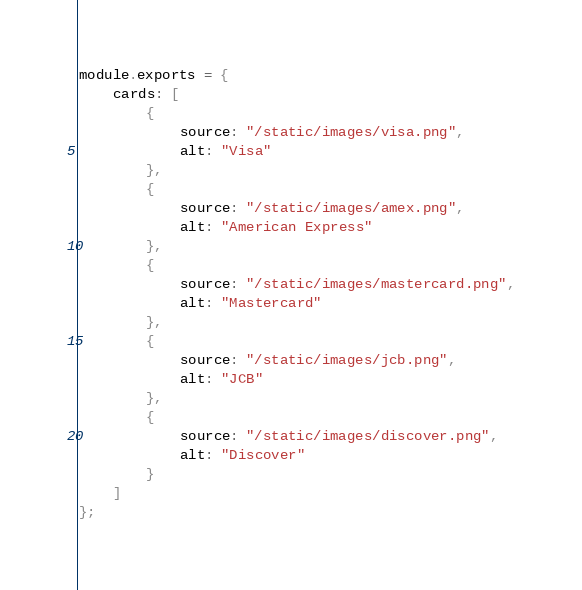<code> <loc_0><loc_0><loc_500><loc_500><_JavaScript_>module.exports = {
	cards: [
		{
			source: "/static/images/visa.png",
			alt: "Visa"
		},
		{
			source: "/static/images/amex.png",
			alt: "American Express"
		},
		{
			source: "/static/images/mastercard.png",
			alt: "Mastercard"
		},
		{
			source: "/static/images/jcb.png",
			alt: "JCB"
		},
		{
			source: "/static/images/discover.png",
			alt: "Discover"
		}
	]
};
</code> 